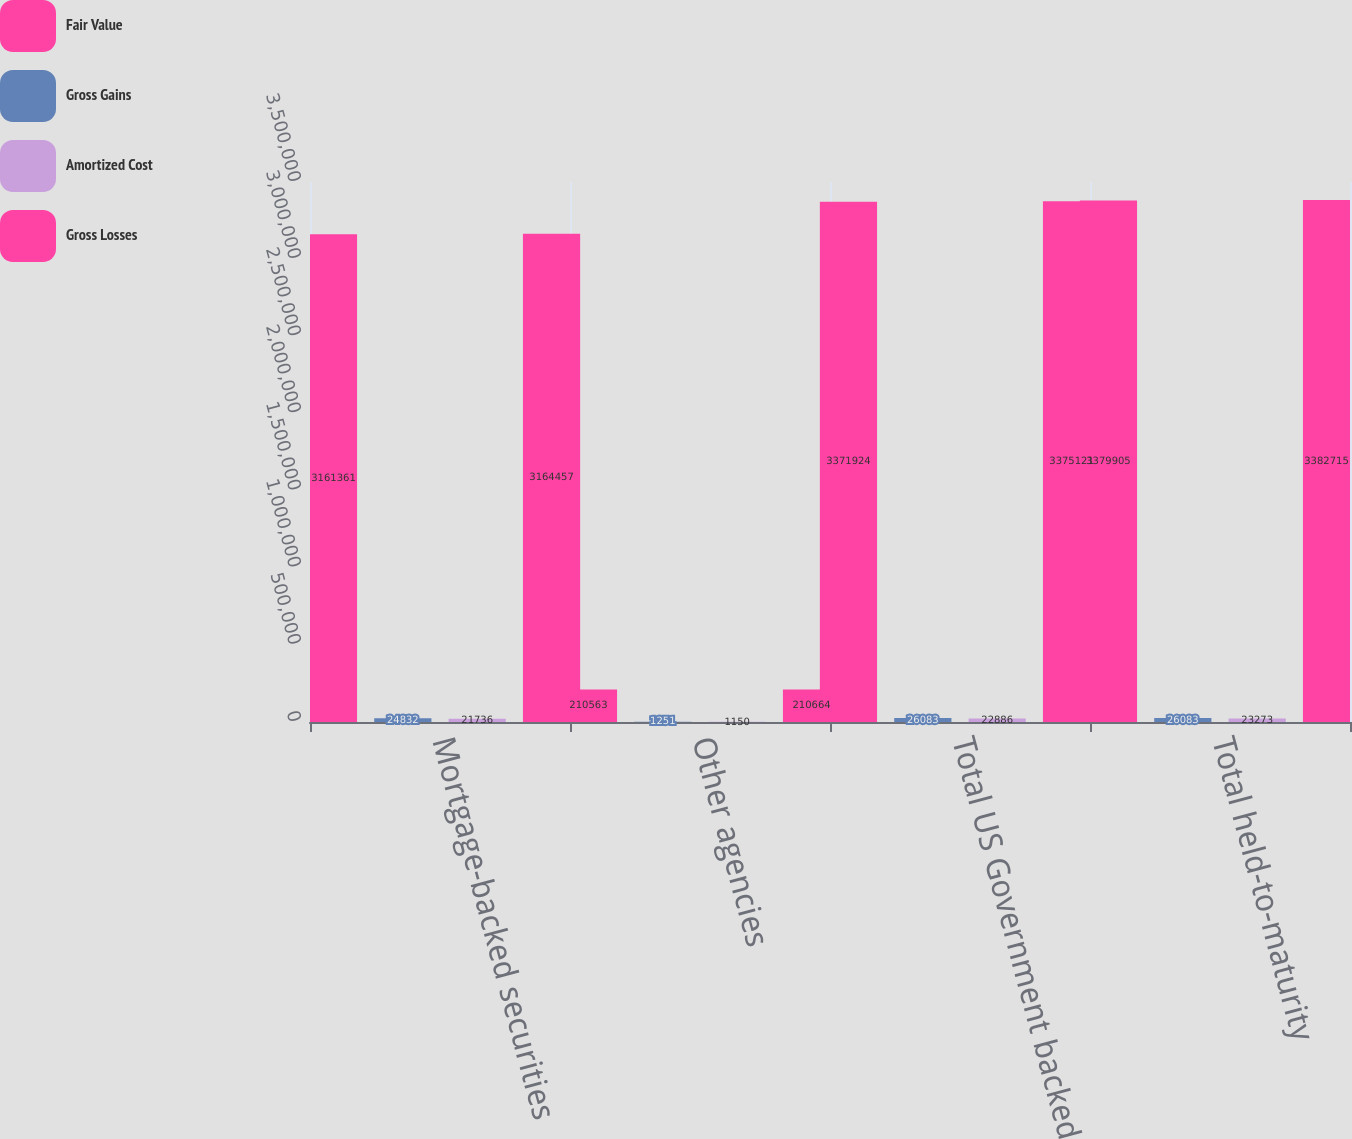Convert chart to OTSL. <chart><loc_0><loc_0><loc_500><loc_500><stacked_bar_chart><ecel><fcel>Mortgage-backed securities<fcel>Other agencies<fcel>Total US Government backed<fcel>Total held-to-maturity<nl><fcel>Fair Value<fcel>3.16136e+06<fcel>210563<fcel>3.37192e+06<fcel>3.3799e+06<nl><fcel>Gross Gains<fcel>24832<fcel>1251<fcel>26083<fcel>26083<nl><fcel>Amortized Cost<fcel>21736<fcel>1150<fcel>22886<fcel>23273<nl><fcel>Gross Losses<fcel>3.16446e+06<fcel>210664<fcel>3.37512e+06<fcel>3.38272e+06<nl></chart> 